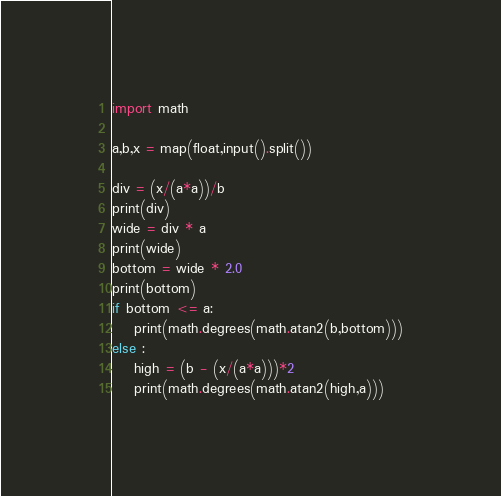<code> <loc_0><loc_0><loc_500><loc_500><_Python_>import math

a,b,x = map(float,input().split())

div = (x/(a*a))/b
print(div)
wide = div * a
print(wide)
bottom = wide * 2.0
print(bottom)
if bottom <= a:
    print(math.degrees(math.atan2(b,bottom)))
else :
    high = (b - (x/(a*a)))*2
    print(math.degrees(math.atan2(high,a)))
</code> 